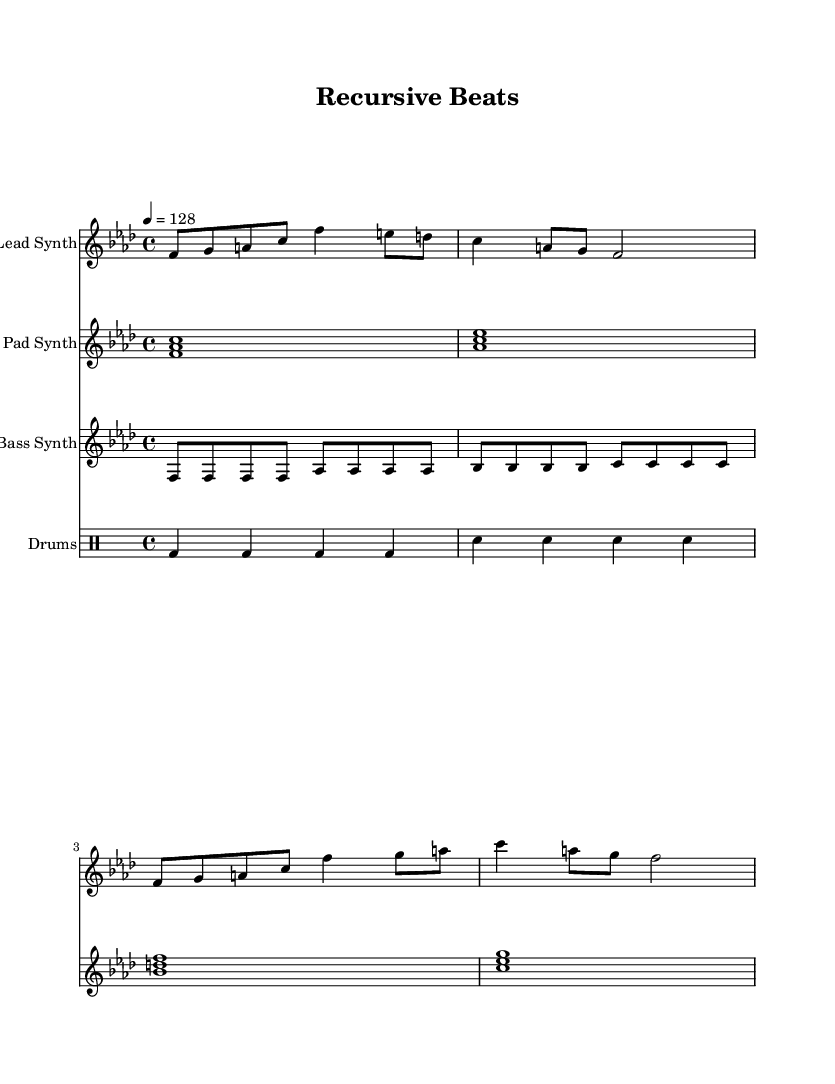What is the key signature of this music? The key signature is F minor, which has four flats (B♭, E♭, A♭, and D♭). This can be determined from the initial part of the sheet music where the key is indicated.
Answer: F minor What is the time signature of this piece? The time signature is 4/4, which means there are four beats in each measure, and the quarter note gets one beat. This is indicated at the beginning of the staff.
Answer: 4/4 What is the tempo marking for this music? The tempo marking is 128 beats per minute, specified in the tempo section of the score. This indicates the speed at which the piece should be played.
Answer: 128 How many measures are present in the lead synth part? The lead synth part contains four measures. By counting the groups of vertical lines (bar lines) in the lead synth section, we can determine the number of measures.
Answer: 4 What type of synthesizer is used for the pad part? The instrument name indicated in the sheet music for the pad synth is "Pad Synth," which is a common reference for a synthesized sound used in house music, known for its ambient qualities.
Answer: Pad Synth How many distinct pitches are used in the bass synth part? The bass synth part includes six distinct pitches which are F, A♭, B♭, C, D♭, and E♭. By identifying each unique note in the bass synth section, we can determine the total.
Answer: 6 What rhythmic element is consistent throughout the drum part? The consistent rhythmic element in the drum part is the quarter note, with bass drum and snare drum patterns being based on this rhythm. This can be seen in the drum staff where the notes are predominantly quarter notes.
Answer: Quarter note 